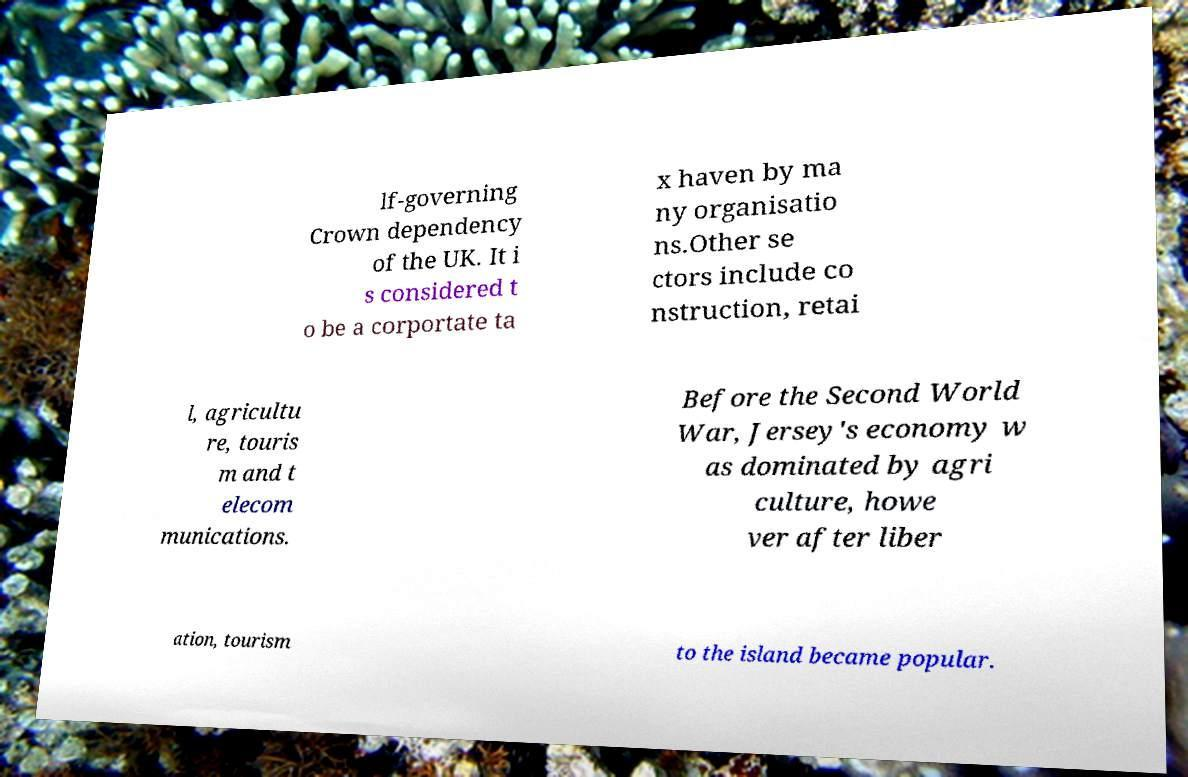What messages or text are displayed in this image? I need them in a readable, typed format. lf-governing Crown dependency of the UK. It i s considered t o be a corportate ta x haven by ma ny organisatio ns.Other se ctors include co nstruction, retai l, agricultu re, touris m and t elecom munications. Before the Second World War, Jersey's economy w as dominated by agri culture, howe ver after liber ation, tourism to the island became popular. 